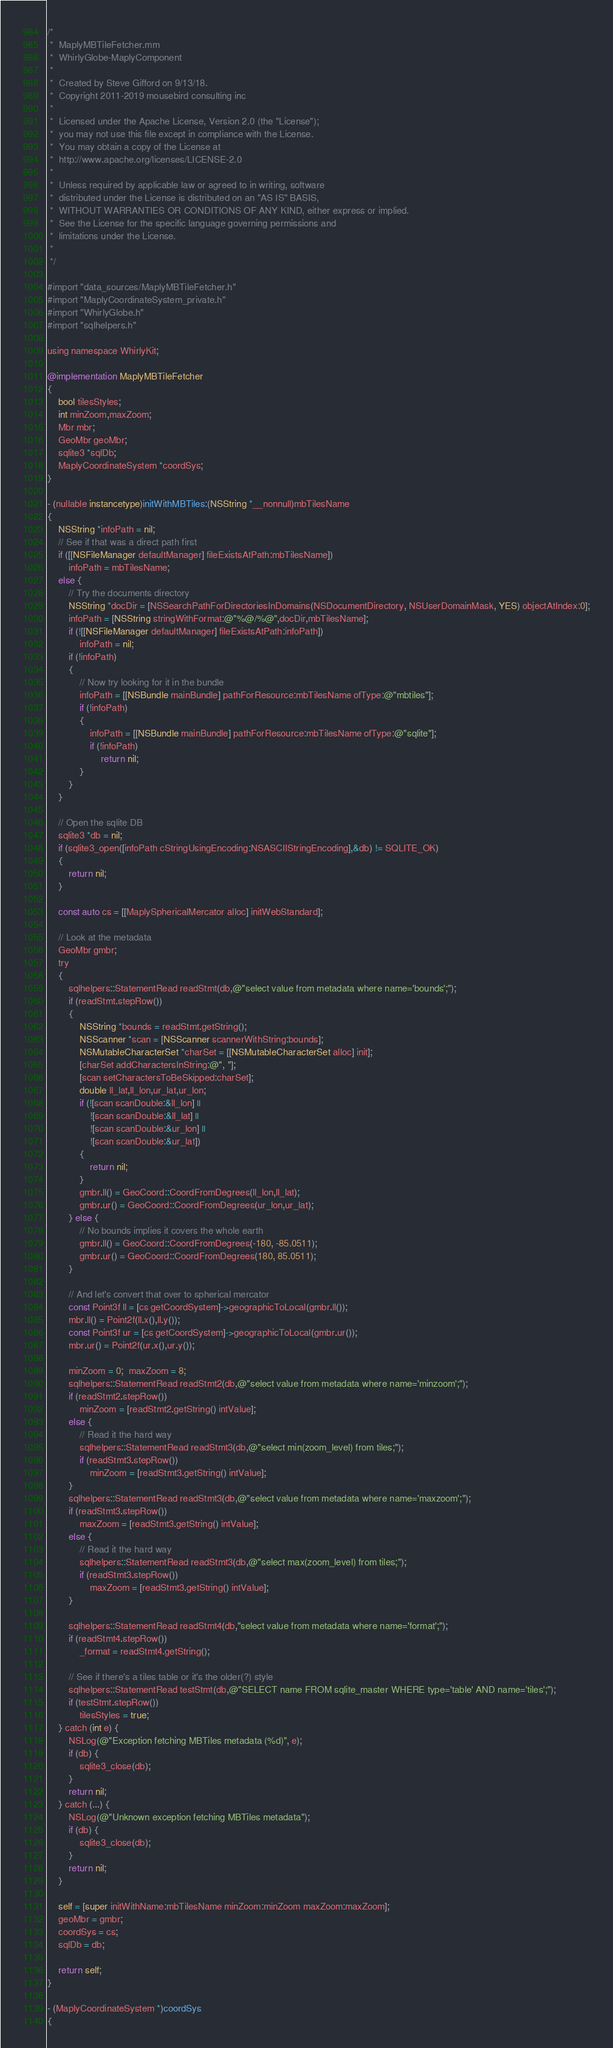<code> <loc_0><loc_0><loc_500><loc_500><_ObjectiveC_>/*
 *  MaplyMBTileFetcher.mm
 *  WhirlyGlobe-MaplyComponent
 *
 *  Created by Steve Gifford on 9/13/18.
 *  Copyright 2011-2019 mousebird consulting inc
 *
 *  Licensed under the Apache License, Version 2.0 (the "License");
 *  you may not use this file except in compliance with the License.
 *  You may obtain a copy of the License at
 *  http://www.apache.org/licenses/LICENSE-2.0
 *
 *  Unless required by applicable law or agreed to in writing, software
 *  distributed under the License is distributed on an "AS IS" BASIS,
 *  WITHOUT WARRANTIES OR CONDITIONS OF ANY KIND, either express or implied.
 *  See the License for the specific language governing permissions and
 *  limitations under the License.
 *
 */

#import "data_sources/MaplyMBTileFetcher.h"
#import "MaplyCoordinateSystem_private.h"
#import "WhirlyGlobe.h"
#import "sqlhelpers.h"

using namespace WhirlyKit;

@implementation MaplyMBTileFetcher
{
    bool tilesStyles;
    int minZoom,maxZoom;
    Mbr mbr;
    GeoMbr geoMbr;
    sqlite3 *sqlDb;
    MaplyCoordinateSystem *coordSys;
}

- (nullable instancetype)initWithMBTiles:(NSString *__nonnull)mbTilesName
{
    NSString *infoPath = nil;
    // See if that was a direct path first
    if ([[NSFileManager defaultManager] fileExistsAtPath:mbTilesName])
        infoPath = mbTilesName;
    else {
        // Try the documents directory
        NSString *docDir = [NSSearchPathForDirectoriesInDomains(NSDocumentDirectory, NSUserDomainMask, YES) objectAtIndex:0];
        infoPath = [NSString stringWithFormat:@"%@/%@",docDir,mbTilesName];
        if (![[NSFileManager defaultManager] fileExistsAtPath:infoPath])
            infoPath = nil;
        if (!infoPath)
        {
            // Now try looking for it in the bundle
            infoPath = [[NSBundle mainBundle] pathForResource:mbTilesName ofType:@"mbtiles"];
            if (!infoPath)
            {
                infoPath = [[NSBundle mainBundle] pathForResource:mbTilesName ofType:@"sqlite"];
                if (!infoPath)
                    return nil;
            }
        }
    }
    
    // Open the sqlite DB
    sqlite3 *db = nil;
    if (sqlite3_open([infoPath cStringUsingEncoding:NSASCIIStringEncoding],&db) != SQLITE_OK)
    {
        return nil;
    }
    
    const auto cs = [[MaplySphericalMercator alloc] initWebStandard];
    
    // Look at the metadata
    GeoMbr gmbr;
    try
    {
        sqlhelpers::StatementRead readStmt(db,@"select value from metadata where name='bounds';");
        if (readStmt.stepRow())
        {
            NSString *bounds = readStmt.getString();
            NSScanner *scan = [NSScanner scannerWithString:bounds];
            NSMutableCharacterSet *charSet = [[NSMutableCharacterSet alloc] init];
            [charSet addCharactersInString:@", "];
            [scan setCharactersToBeSkipped:charSet];
            double ll_lat,ll_lon,ur_lat,ur_lon;
            if (![scan scanDouble:&ll_lon] ||
                ![scan scanDouble:&ll_lat] ||
                ![scan scanDouble:&ur_lon] ||
                ![scan scanDouble:&ur_lat])
            {
                return nil;
            }
            gmbr.ll() = GeoCoord::CoordFromDegrees(ll_lon,ll_lat);
            gmbr.ur() = GeoCoord::CoordFromDegrees(ur_lon,ur_lat);
        } else {
            // No bounds implies it covers the whole earth
            gmbr.ll() = GeoCoord::CoordFromDegrees(-180, -85.0511);
            gmbr.ur() = GeoCoord::CoordFromDegrees(180, 85.0511);
        }
        
        // And let's convert that over to spherical mercator
        const Point3f ll = [cs getCoordSystem]->geographicToLocal(gmbr.ll());
        mbr.ll() = Point2f(ll.x(),ll.y());
        const Point3f ur = [cs getCoordSystem]->geographicToLocal(gmbr.ur());
        mbr.ur() = Point2f(ur.x(),ur.y());

        minZoom = 0;  maxZoom = 8;
        sqlhelpers::StatementRead readStmt2(db,@"select value from metadata where name='minzoom';");
        if (readStmt2.stepRow())
            minZoom = [readStmt2.getString() intValue];
        else {
            // Read it the hard way
            sqlhelpers::StatementRead readStmt3(db,@"select min(zoom_level) from tiles;");
            if (readStmt3.stepRow())
                minZoom = [readStmt3.getString() intValue];
        }
        sqlhelpers::StatementRead readStmt3(db,@"select value from metadata where name='maxzoom';");
        if (readStmt3.stepRow())
            maxZoom = [readStmt3.getString() intValue];
        else {
            // Read it the hard way
            sqlhelpers::StatementRead readStmt3(db,@"select max(zoom_level) from tiles;");
            if (readStmt3.stepRow())
                maxZoom = [readStmt3.getString() intValue];
        }
        
        sqlhelpers::StatementRead readStmt4(db,"select value from metadata where name='format';");
        if (readStmt4.stepRow())
            _format = readStmt4.getString();
        
        // See if there's a tiles table or it's the older(?) style
        sqlhelpers::StatementRead testStmt(db,@"SELECT name FROM sqlite_master WHERE type='table' AND name='tiles';");
        if (testStmt.stepRow())
            tilesStyles = true;
    } catch (int e) {
        NSLog(@"Exception fetching MBTiles metadata (%d)", e);
        if (db) {
            sqlite3_close(db);
        }
        return nil;
    } catch (...) {
        NSLog(@"Unknown exception fetching MBTiles metadata");
        if (db) {
            sqlite3_close(db);
        }
        return nil;
    }

    self = [super initWithName:mbTilesName minZoom:minZoom maxZoom:maxZoom];
    geoMbr = gmbr;
    coordSys = cs;
    sqlDb = db;
    
    return self;
}

- (MaplyCoordinateSystem *)coordSys
{</code> 